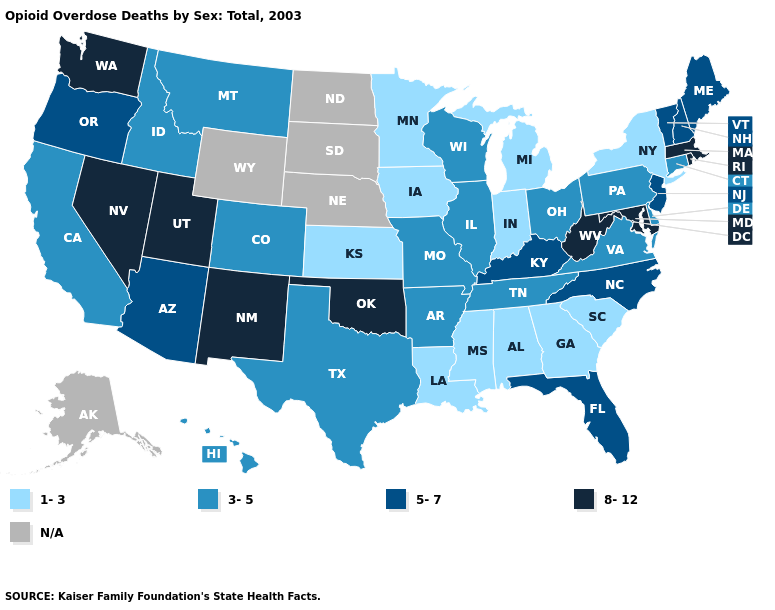What is the highest value in the Northeast ?
Answer briefly. 8-12. What is the lowest value in the West?
Write a very short answer. 3-5. Which states have the highest value in the USA?
Concise answer only. Maryland, Massachusetts, Nevada, New Mexico, Oklahoma, Rhode Island, Utah, Washington, West Virginia. Which states hav the highest value in the West?
Short answer required. Nevada, New Mexico, Utah, Washington. Which states have the lowest value in the West?
Short answer required. California, Colorado, Hawaii, Idaho, Montana. Name the states that have a value in the range 8-12?
Concise answer only. Maryland, Massachusetts, Nevada, New Mexico, Oklahoma, Rhode Island, Utah, Washington, West Virginia. Name the states that have a value in the range 3-5?
Answer briefly. Arkansas, California, Colorado, Connecticut, Delaware, Hawaii, Idaho, Illinois, Missouri, Montana, Ohio, Pennsylvania, Tennessee, Texas, Virginia, Wisconsin. Name the states that have a value in the range 1-3?
Keep it brief. Alabama, Georgia, Indiana, Iowa, Kansas, Louisiana, Michigan, Minnesota, Mississippi, New York, South Carolina. What is the lowest value in the USA?
Be succinct. 1-3. Which states hav the highest value in the South?
Short answer required. Maryland, Oklahoma, West Virginia. Does Tennessee have the highest value in the USA?
Answer briefly. No. Is the legend a continuous bar?
Write a very short answer. No. Among the states that border Vermont , which have the highest value?
Quick response, please. Massachusetts. 